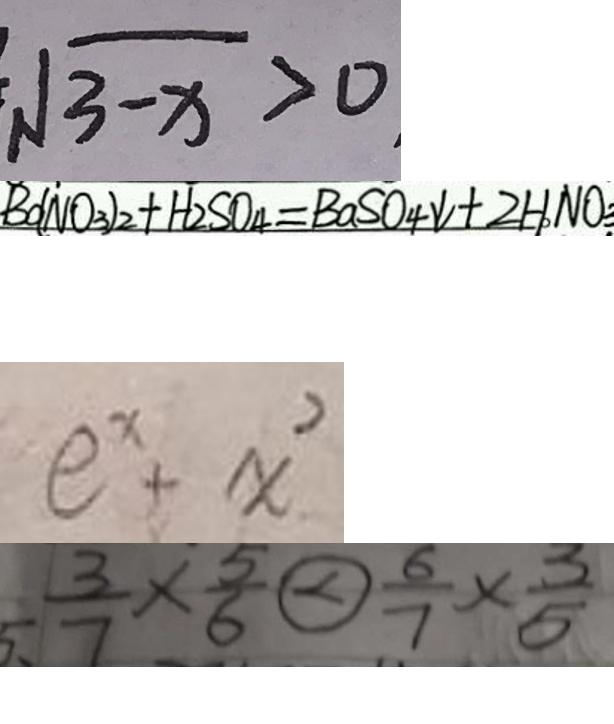<formula> <loc_0><loc_0><loc_500><loc_500>\sqrt { 3 - x } > 0 
 B o ( N O _ { 3 } ) _ { 2 } + H _ { 2 } S O _ { 4 } = B a S O _ { 4 } \downarrow + 2 H N O _ { 3 } 
 e ^ { x } + x ^ { 2 } 
 5 、 \frac { 3 } { 7 } \times \frac { 5 } { 6 } \textcircled { < } \frac { 6 } { 7 } \times \frac { 3 } { 5 }</formula> 